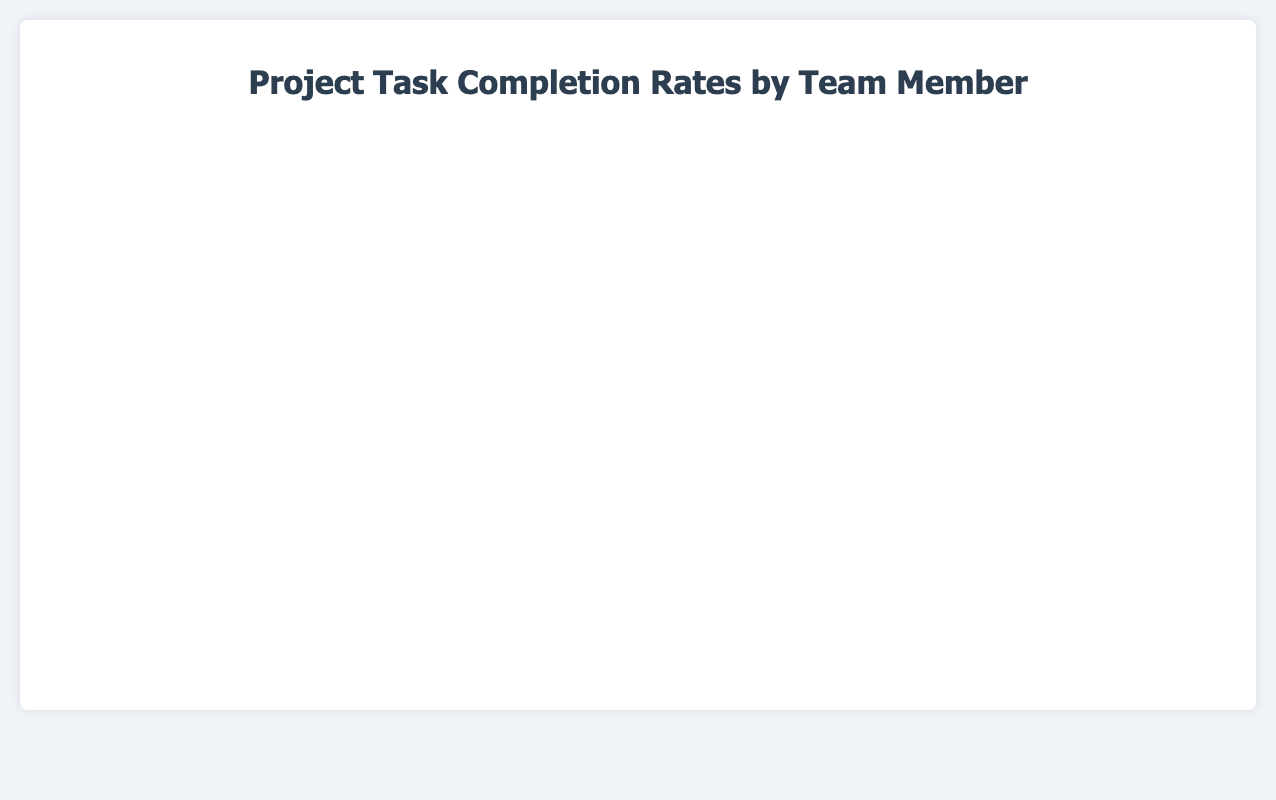What is the overall trend in the task completion rates? The overall trend in the task completion rates shows a steady increase over time for all team members. From January to May, the number of tasks completed generally rises in a linear fashion for each member.
Answer: Steady increase Which team member completed the most tasks by May 15, 2023? By looking at the end of the timeline on May 15, 2023, Alice Johnson completed the most tasks, with 55 tasks completed.
Answer: Alice Johnson Which team member had the smallest increase in tasks from January 1 to February 1, 2023? For the period between January 1 and February 1, 2023, Charles Lee had the smallest increase in tasks, with an increase of 7 tasks (from 2 to 9).
Answer: Charles Lee How many tasks had Bob Smith completed by mid-February 2023? By observing the data point on February 15, 2023, Bob Smith had completed 22 tasks.
Answer: 22 tasks What is the maximum difference in task completion rates between any two team members on March 1, 2023? On March 1, 2023, Alice Johnson and Ethan Martinez have the highest and lowest task completions with 30 and 21 tasks, respectively. The difference is 30 - 21 = 9 tasks.
Answer: 9 tasks Which team member had the most consistent progress in task completion rates over the project's timeline? Diana Davis had the most consistent progress, with a steady increase in the number of tasks completed at each interval without large fluctuations.
Answer: Diana Davis Is there any month where the task completion rates plateau for any team member? In the period from March 15 to April 1, both Alice Johnson and Bob Smith have similar rates, with small increases, indicating a possible plateau.
Answer: March 15 to April 1 Between April 1 and May 1, 2023, which team member showed the highest increase in task completion? During this period, Alice Johnson showed the highest increase, adding 8 tasks (from 42 to 50).
Answer: Alice Johnson Who had completed more tasks by February 15, 2023, Diana Davis or Ethan Martinez? By February 15, 2023, Diana Davis had completed 20 tasks, whereas Ethan Martinez had completed 17 tasks. Hence, Diana Davis had completed more tasks.
Answer: Diana Davis 